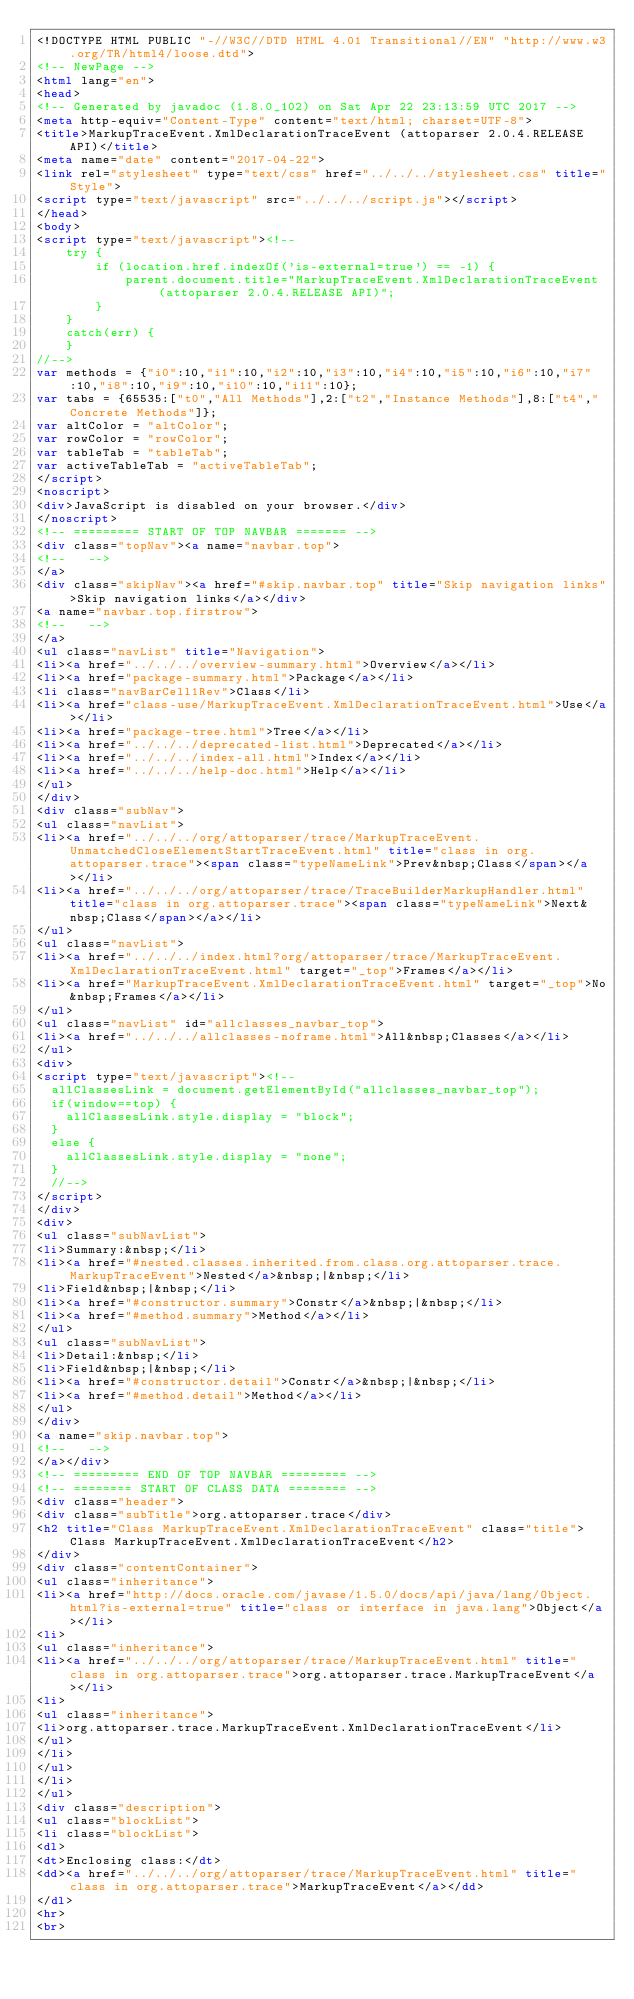Convert code to text. <code><loc_0><loc_0><loc_500><loc_500><_HTML_><!DOCTYPE HTML PUBLIC "-//W3C//DTD HTML 4.01 Transitional//EN" "http://www.w3.org/TR/html4/loose.dtd">
<!-- NewPage -->
<html lang="en">
<head>
<!-- Generated by javadoc (1.8.0_102) on Sat Apr 22 23:13:59 UTC 2017 -->
<meta http-equiv="Content-Type" content="text/html; charset=UTF-8">
<title>MarkupTraceEvent.XmlDeclarationTraceEvent (attoparser 2.0.4.RELEASE API)</title>
<meta name="date" content="2017-04-22">
<link rel="stylesheet" type="text/css" href="../../../stylesheet.css" title="Style">
<script type="text/javascript" src="../../../script.js"></script>
</head>
<body>
<script type="text/javascript"><!--
    try {
        if (location.href.indexOf('is-external=true') == -1) {
            parent.document.title="MarkupTraceEvent.XmlDeclarationTraceEvent (attoparser 2.0.4.RELEASE API)";
        }
    }
    catch(err) {
    }
//-->
var methods = {"i0":10,"i1":10,"i2":10,"i3":10,"i4":10,"i5":10,"i6":10,"i7":10,"i8":10,"i9":10,"i10":10,"i11":10};
var tabs = {65535:["t0","All Methods"],2:["t2","Instance Methods"],8:["t4","Concrete Methods"]};
var altColor = "altColor";
var rowColor = "rowColor";
var tableTab = "tableTab";
var activeTableTab = "activeTableTab";
</script>
<noscript>
<div>JavaScript is disabled on your browser.</div>
</noscript>
<!-- ========= START OF TOP NAVBAR ======= -->
<div class="topNav"><a name="navbar.top">
<!--   -->
</a>
<div class="skipNav"><a href="#skip.navbar.top" title="Skip navigation links">Skip navigation links</a></div>
<a name="navbar.top.firstrow">
<!--   -->
</a>
<ul class="navList" title="Navigation">
<li><a href="../../../overview-summary.html">Overview</a></li>
<li><a href="package-summary.html">Package</a></li>
<li class="navBarCell1Rev">Class</li>
<li><a href="class-use/MarkupTraceEvent.XmlDeclarationTraceEvent.html">Use</a></li>
<li><a href="package-tree.html">Tree</a></li>
<li><a href="../../../deprecated-list.html">Deprecated</a></li>
<li><a href="../../../index-all.html">Index</a></li>
<li><a href="../../../help-doc.html">Help</a></li>
</ul>
</div>
<div class="subNav">
<ul class="navList">
<li><a href="../../../org/attoparser/trace/MarkupTraceEvent.UnmatchedCloseElementStartTraceEvent.html" title="class in org.attoparser.trace"><span class="typeNameLink">Prev&nbsp;Class</span></a></li>
<li><a href="../../../org/attoparser/trace/TraceBuilderMarkupHandler.html" title="class in org.attoparser.trace"><span class="typeNameLink">Next&nbsp;Class</span></a></li>
</ul>
<ul class="navList">
<li><a href="../../../index.html?org/attoparser/trace/MarkupTraceEvent.XmlDeclarationTraceEvent.html" target="_top">Frames</a></li>
<li><a href="MarkupTraceEvent.XmlDeclarationTraceEvent.html" target="_top">No&nbsp;Frames</a></li>
</ul>
<ul class="navList" id="allclasses_navbar_top">
<li><a href="../../../allclasses-noframe.html">All&nbsp;Classes</a></li>
</ul>
<div>
<script type="text/javascript"><!--
  allClassesLink = document.getElementById("allclasses_navbar_top");
  if(window==top) {
    allClassesLink.style.display = "block";
  }
  else {
    allClassesLink.style.display = "none";
  }
  //-->
</script>
</div>
<div>
<ul class="subNavList">
<li>Summary:&nbsp;</li>
<li><a href="#nested.classes.inherited.from.class.org.attoparser.trace.MarkupTraceEvent">Nested</a>&nbsp;|&nbsp;</li>
<li>Field&nbsp;|&nbsp;</li>
<li><a href="#constructor.summary">Constr</a>&nbsp;|&nbsp;</li>
<li><a href="#method.summary">Method</a></li>
</ul>
<ul class="subNavList">
<li>Detail:&nbsp;</li>
<li>Field&nbsp;|&nbsp;</li>
<li><a href="#constructor.detail">Constr</a>&nbsp;|&nbsp;</li>
<li><a href="#method.detail">Method</a></li>
</ul>
</div>
<a name="skip.navbar.top">
<!--   -->
</a></div>
<!-- ========= END OF TOP NAVBAR ========= -->
<!-- ======== START OF CLASS DATA ======== -->
<div class="header">
<div class="subTitle">org.attoparser.trace</div>
<h2 title="Class MarkupTraceEvent.XmlDeclarationTraceEvent" class="title">Class MarkupTraceEvent.XmlDeclarationTraceEvent</h2>
</div>
<div class="contentContainer">
<ul class="inheritance">
<li><a href="http://docs.oracle.com/javase/1.5.0/docs/api/java/lang/Object.html?is-external=true" title="class or interface in java.lang">Object</a></li>
<li>
<ul class="inheritance">
<li><a href="../../../org/attoparser/trace/MarkupTraceEvent.html" title="class in org.attoparser.trace">org.attoparser.trace.MarkupTraceEvent</a></li>
<li>
<ul class="inheritance">
<li>org.attoparser.trace.MarkupTraceEvent.XmlDeclarationTraceEvent</li>
</ul>
</li>
</ul>
</li>
</ul>
<div class="description">
<ul class="blockList">
<li class="blockList">
<dl>
<dt>Enclosing class:</dt>
<dd><a href="../../../org/attoparser/trace/MarkupTraceEvent.html" title="class in org.attoparser.trace">MarkupTraceEvent</a></dd>
</dl>
<hr>
<br></code> 